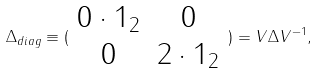<formula> <loc_0><loc_0><loc_500><loc_500>\Delta _ { d i a g } \equiv ( \begin{array} { c c } 0 \cdot 1 _ { 2 } & 0 \\ 0 & 2 \cdot 1 _ { 2 } \end{array} ) = V \Delta V ^ { - 1 } ,</formula> 